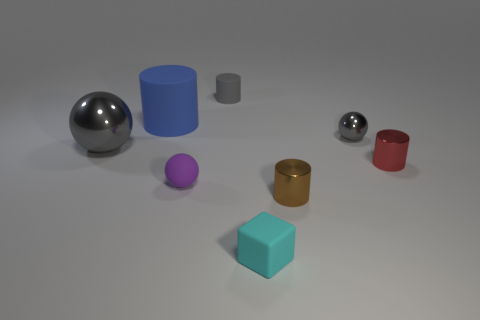Subtract all brown cylinders. How many cylinders are left? 3 Subtract all brown cylinders. How many cylinders are left? 3 Subtract all cyan cylinders. Subtract all blue cubes. How many cylinders are left? 4 Add 1 gray metal objects. How many objects exist? 9 Subtract all spheres. How many objects are left? 5 Subtract 1 brown cylinders. How many objects are left? 7 Subtract all small cyan cubes. Subtract all tiny cyan rubber blocks. How many objects are left? 6 Add 3 tiny metallic objects. How many tiny metallic objects are left? 6 Add 4 tiny purple objects. How many tiny purple objects exist? 5 